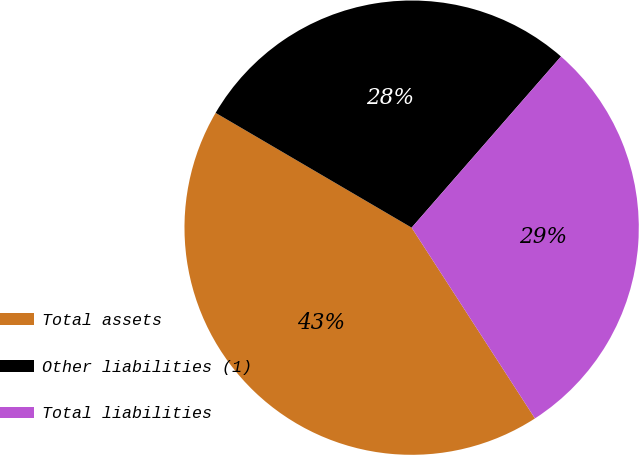Convert chart to OTSL. <chart><loc_0><loc_0><loc_500><loc_500><pie_chart><fcel>Total assets<fcel>Other liabilities (1)<fcel>Total liabilities<nl><fcel>42.57%<fcel>27.99%<fcel>29.45%<nl></chart> 